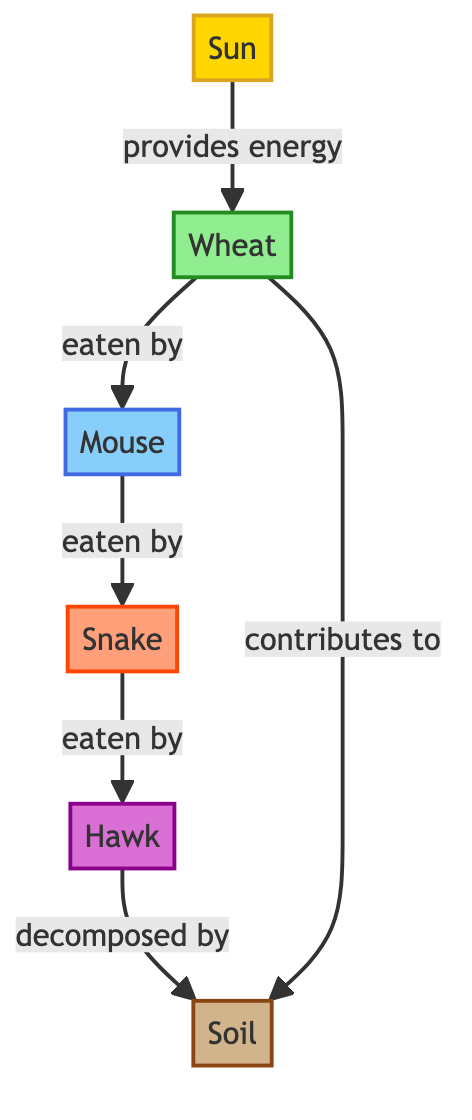What is the primary producer in this food chain? The diagram identifies "Wheat" as the primary producer, which is the first level in the food chain that converts sunlight into energy through photosynthesis.
Answer: Wheat How many consumers are present in the food chain? The diagram shows three levels of consumers: the primary consumer (mouse), secondary consumer (snake), and tertiary consumer (hawk), which totals to three consumers.
Answer: 3 Which organism is directly eaten by the snake? According to the diagram, the "Mouse" is the organism that is directly consumed by the snake, establishing a predator-prey relationship between the two.
Answer: Mouse What role does soil play in this food chain? The diagram illustrates that "Soil" acts as a decomposer, which breaks down organic matter and recycles nutrients back into the ecosystem, thus supporting plant growth.
Answer: Decomposer What is the relationship between wheat and soil? The diagram indicates that wheat contributes to soil by returning nutrients when it decomposes, demonstrating an essential connection between the primary producer and the decomposer.
Answer: Contributes to What kind of energy does the sun provide in this food chain? The diagram explicitly states that the sun provides energy to the wheat, indicating that it serves as the initial energy source for the entire food chain by facilitating photosynthesis in plants.
Answer: Energy What would happen if the mouse population decreases significantly? With a significant decrease in the mouse population, the snake population would likely decline as well due to reduced food availability, demonstrating the interconnectedness of species in the food chain.
Answer: Decline Which organism is at the highest trophic level? The diagram marks the "Hawk" as the tertiary consumer, which occupies the highest trophic level in this specific food chain, showing its role as a top predator.
Answer: Hawk What happens to the hawk after it decomposes? The diagram indicates that the hawk is decomposed by the soil, which emphasizes the cycle of energy and nutrients within the food chain, as decomposers play a crucial role in recycling matter.
Answer: Decomposed by What is the primary source of energy for the food chain? The diagram clearly shows that the "Sun" is the primary source of energy that fuels the food chain, as it is the initiating point for the energy transfer to producers.
Answer: Sun 